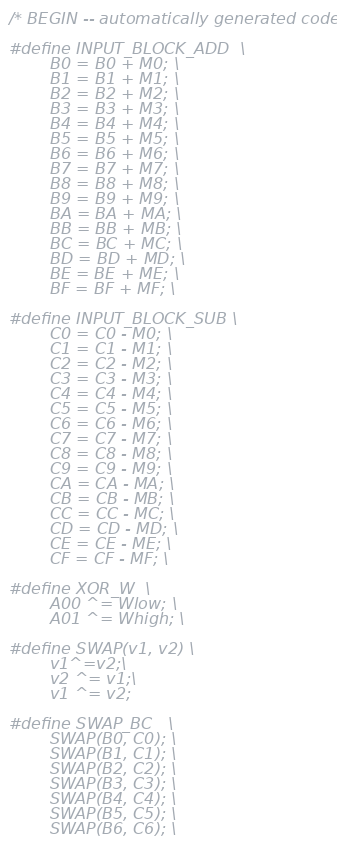Convert code to text. <code><loc_0><loc_0><loc_500><loc_500><_Cuda_>
/* BEGIN -- automatically generated code. */

#define INPUT_BLOCK_ADD  \
		B0 = B0 + M0; \
		B1 = B1 + M1; \
		B2 = B2 + M2; \
		B3 = B3 + M3; \
		B4 = B4 + M4; \
		B5 = B5 + M5; \
		B6 = B6 + M6; \
		B7 = B7 + M7; \
		B8 = B8 + M8; \
		B9 = B9 + M9; \
		BA = BA + MA; \
		BB = BB + MB; \
		BC = BC + MC; \
		BD = BD + MD; \
		BE = BE + ME; \
		BF = BF + MF; \

#define INPUT_BLOCK_SUB \
		C0 = C0 - M0; \
		C1 = C1 - M1; \
		C2 = C2 - M2; \
		C3 = C3 - M3; \
		C4 = C4 - M4; \
		C5 = C5 - M5; \
		C6 = C6 - M6; \
		C7 = C7 - M7; \
		C8 = C8 - M8; \
		C9 = C9 - M9; \
		CA = CA - MA; \
		CB = CB - MB; \
		CC = CC - MC; \
		CD = CD - MD; \
		CE = CE - ME; \
		CF = CF - MF; \

#define XOR_W  \
		A00 ^= Wlow; \
		A01 ^= Whigh; \

#define SWAP(v1, v2) \
		v1^=v2;\
		v2 ^= v1;\
		v1 ^= v2;

#define SWAP_BC   \
		SWAP(B0, C0); \
		SWAP(B1, C1); \
		SWAP(B2, C2); \
		SWAP(B3, C3); \
		SWAP(B4, C4); \
		SWAP(B5, C5); \
		SWAP(B6, C6); \</code> 